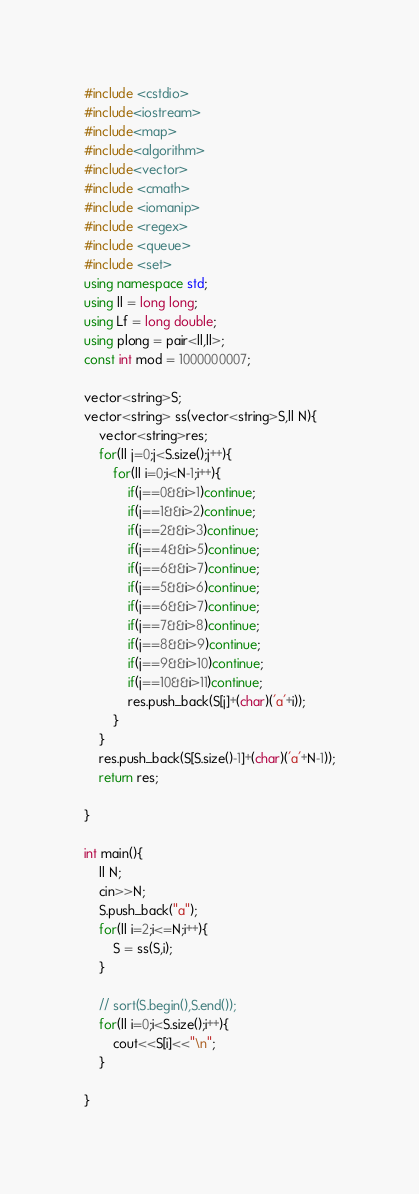Convert code to text. <code><loc_0><loc_0><loc_500><loc_500><_C++_>#include <cstdio>
#include<iostream>
#include<map>
#include<algorithm>
#include<vector>
#include <cmath>
#include <iomanip>
#include <regex>
#include <queue>
#include <set>
using namespace std;
using ll = long long;
using Lf = long double;
using plong = pair<ll,ll>;
const int mod = 1000000007;
 
vector<string>S;
vector<string> ss(vector<string>S,ll N){
    vector<string>res;
    for(ll j=0;j<S.size();j++){
        for(ll i=0;i<N-1;i++){
            if(j==0&&i>1)continue;
            if(j==1&&i>2)continue;
            if(j==2&&i>3)continue;
            if(j==4&&i>5)continue;
            if(j==6&&i>7)continue;
            if(j==5&&i>6)continue;
            if(j==6&&i>7)continue;
            if(j==7&&i>8)continue;
            if(j==8&&i>9)continue;
            if(j==9&&i>10)continue;
            if(j==10&&i>11)continue;
            res.push_back(S[j]+(char)('a'+i));
        }
    }
    res.push_back(S[S.size()-1]+(char)('a'+N-1));
    return res;

}

int main(){
    ll N;
    cin>>N;
    S.push_back("a");
    for(ll i=2;i<=N;i++){
        S = ss(S,i);
    }

    // sort(S.begin(),S.end());
    for(ll i=0;i<S.size();i++){
        cout<<S[i]<<"\n";
    }
 
}</code> 